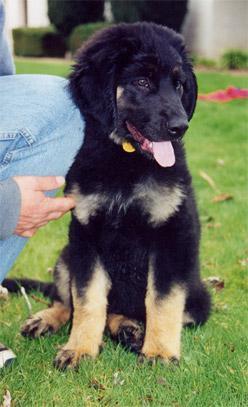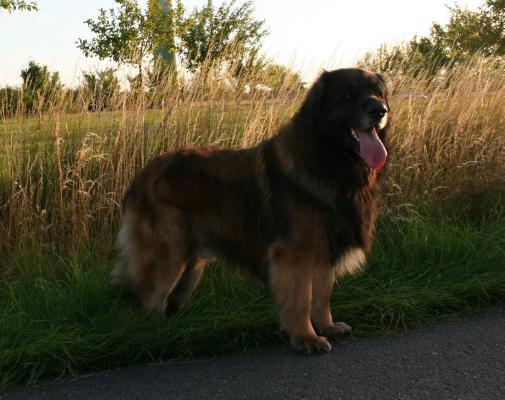The first image is the image on the left, the second image is the image on the right. For the images displayed, is the sentence "Exactly one of the dogs is shown standing in profile on all fours in the grass." factually correct? Answer yes or no. Yes. 